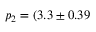<formula> <loc_0><loc_0><loc_500><loc_500>p _ { 2 } = ( 3 . 3 \pm 0 . 3 9</formula> 